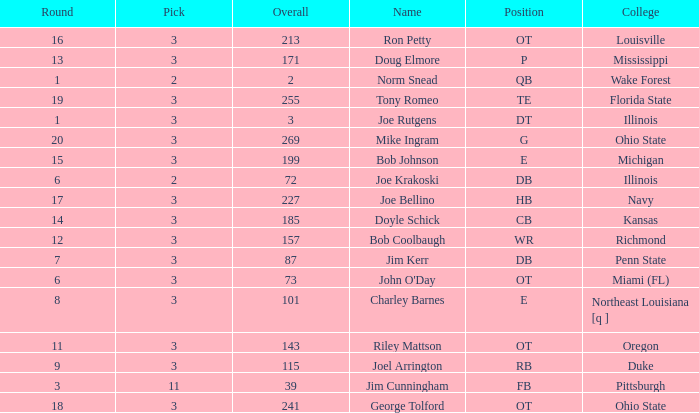How many rounds have john o'day as the name, and a pick less than 3? None. 